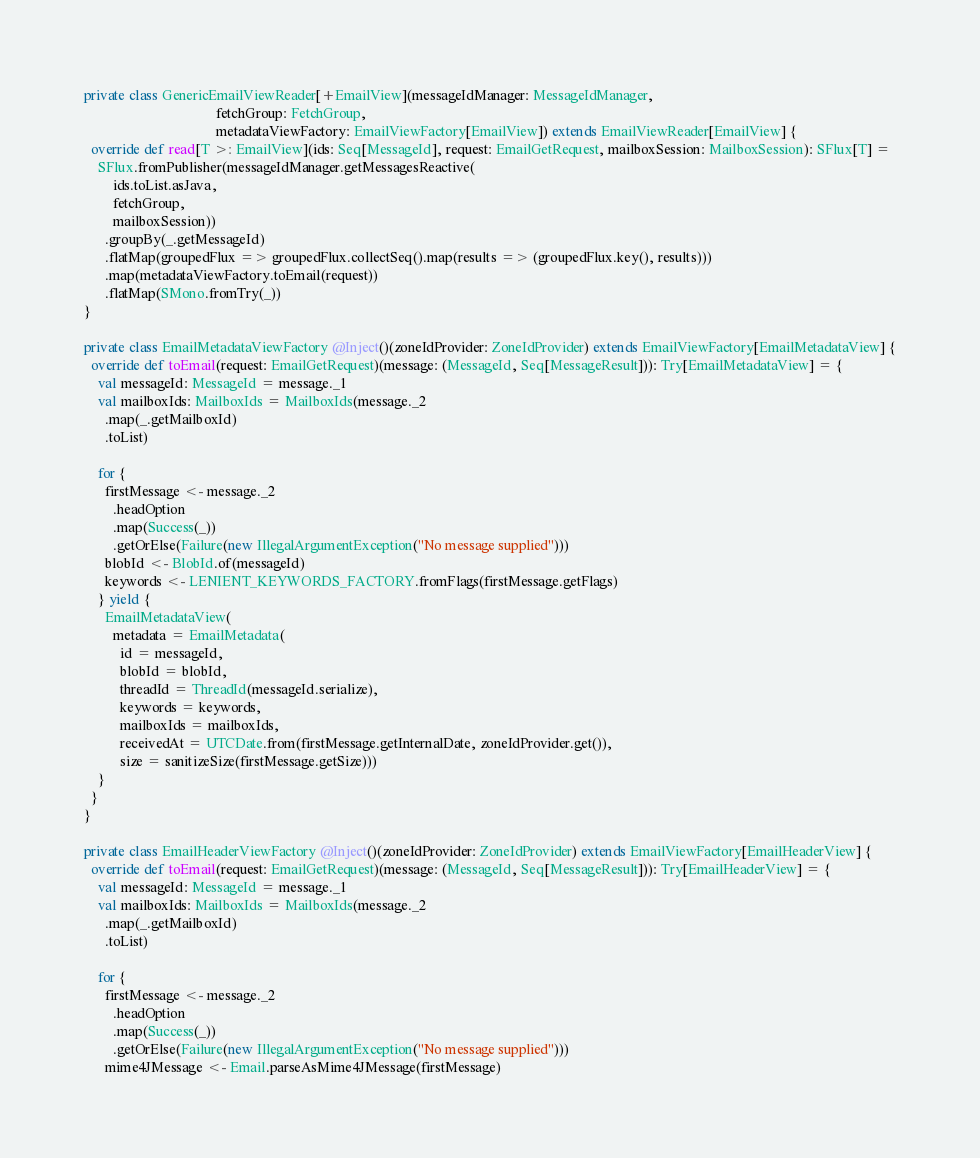<code> <loc_0><loc_0><loc_500><loc_500><_Scala_>
private class GenericEmailViewReader[+EmailView](messageIdManager: MessageIdManager,
                                     fetchGroup: FetchGroup,
                                     metadataViewFactory: EmailViewFactory[EmailView]) extends EmailViewReader[EmailView] {
  override def read[T >: EmailView](ids: Seq[MessageId], request: EmailGetRequest, mailboxSession: MailboxSession): SFlux[T] =
    SFlux.fromPublisher(messageIdManager.getMessagesReactive(
        ids.toList.asJava,
        fetchGroup,
        mailboxSession))
      .groupBy(_.getMessageId)
      .flatMap(groupedFlux => groupedFlux.collectSeq().map(results => (groupedFlux.key(), results)))
      .map(metadataViewFactory.toEmail(request))
      .flatMap(SMono.fromTry(_))
}

private class EmailMetadataViewFactory @Inject()(zoneIdProvider: ZoneIdProvider) extends EmailViewFactory[EmailMetadataView] {
  override def toEmail(request: EmailGetRequest)(message: (MessageId, Seq[MessageResult])): Try[EmailMetadataView] = {
    val messageId: MessageId = message._1
    val mailboxIds: MailboxIds = MailboxIds(message._2
      .map(_.getMailboxId)
      .toList)

    for {
      firstMessage <- message._2
        .headOption
        .map(Success(_))
        .getOrElse(Failure(new IllegalArgumentException("No message supplied")))
      blobId <- BlobId.of(messageId)
      keywords <- LENIENT_KEYWORDS_FACTORY.fromFlags(firstMessage.getFlags)
    } yield {
      EmailMetadataView(
        metadata = EmailMetadata(
          id = messageId,
          blobId = blobId,
          threadId = ThreadId(messageId.serialize),
          keywords = keywords,
          mailboxIds = mailboxIds,
          receivedAt = UTCDate.from(firstMessage.getInternalDate, zoneIdProvider.get()),
          size = sanitizeSize(firstMessage.getSize)))
    }
  }
}

private class EmailHeaderViewFactory @Inject()(zoneIdProvider: ZoneIdProvider) extends EmailViewFactory[EmailHeaderView] {
  override def toEmail(request: EmailGetRequest)(message: (MessageId, Seq[MessageResult])): Try[EmailHeaderView] = {
    val messageId: MessageId = message._1
    val mailboxIds: MailboxIds = MailboxIds(message._2
      .map(_.getMailboxId)
      .toList)

    for {
      firstMessage <- message._2
        .headOption
        .map(Success(_))
        .getOrElse(Failure(new IllegalArgumentException("No message supplied")))
      mime4JMessage <- Email.parseAsMime4JMessage(firstMessage)</code> 